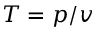Convert formula to latex. <formula><loc_0><loc_0><loc_500><loc_500>T = p / v</formula> 